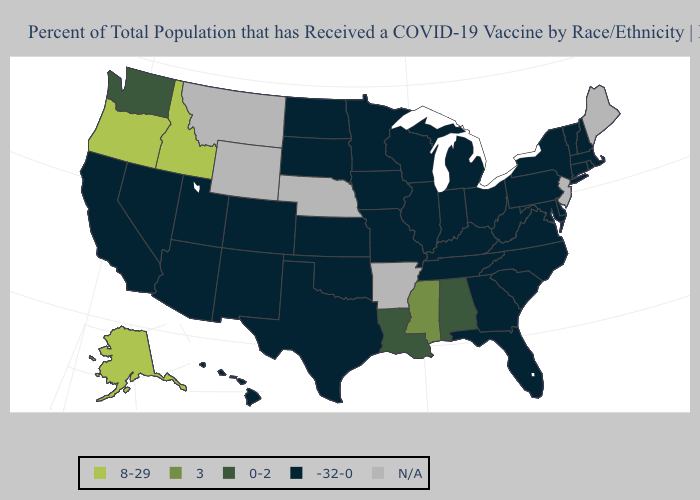Name the states that have a value in the range 0-2?
Be succinct. Alabama, Louisiana, Washington. What is the value of Oklahoma?
Concise answer only. -32-0. Among the states that border New Mexico , which have the highest value?
Concise answer only. Arizona, Colorado, Oklahoma, Texas, Utah. Does Kansas have the lowest value in the USA?
Answer briefly. Yes. Which states have the highest value in the USA?
Quick response, please. Alaska, Idaho, Oregon. What is the value of Minnesota?
Quick response, please. -32-0. What is the highest value in the South ?
Quick response, please. 3. What is the value of Kansas?
Give a very brief answer. -32-0. What is the value of Washington?
Answer briefly. 0-2. Name the states that have a value in the range -32-0?
Write a very short answer. Arizona, California, Colorado, Connecticut, Delaware, Florida, Georgia, Hawaii, Illinois, Indiana, Iowa, Kansas, Kentucky, Maryland, Massachusetts, Michigan, Minnesota, Missouri, Nevada, New Hampshire, New Mexico, New York, North Carolina, North Dakota, Ohio, Oklahoma, Pennsylvania, Rhode Island, South Carolina, South Dakota, Tennessee, Texas, Utah, Vermont, Virginia, West Virginia, Wisconsin. Among the states that border Pennsylvania , which have the lowest value?
Quick response, please. Delaware, Maryland, New York, Ohio, West Virginia. Does Oregon have the highest value in the USA?
Quick response, please. Yes. What is the value of Utah?
Answer briefly. -32-0. Does Oklahoma have the lowest value in the USA?
Concise answer only. Yes. 